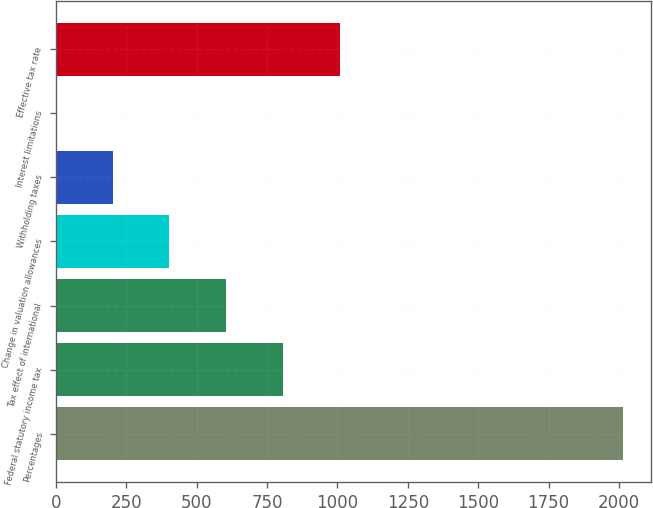<chart> <loc_0><loc_0><loc_500><loc_500><bar_chart><fcel>Percentages<fcel>Federal statutory income tax<fcel>Tax effect of international<fcel>Change in valuation allowances<fcel>Withholding taxes<fcel>Interest limitations<fcel>Effective tax rate<nl><fcel>2014<fcel>806.08<fcel>604.76<fcel>403.44<fcel>202.12<fcel>0.8<fcel>1007.4<nl></chart> 